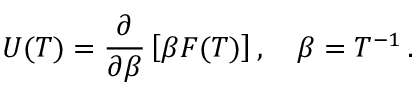Convert formula to latex. <formula><loc_0><loc_0><loc_500><loc_500>U ( T ) = \frac { \partial } { \partial \beta } \left [ \beta F ( T ) \right ] , \quad \beta = T ^ { - 1 } \, { . }</formula> 